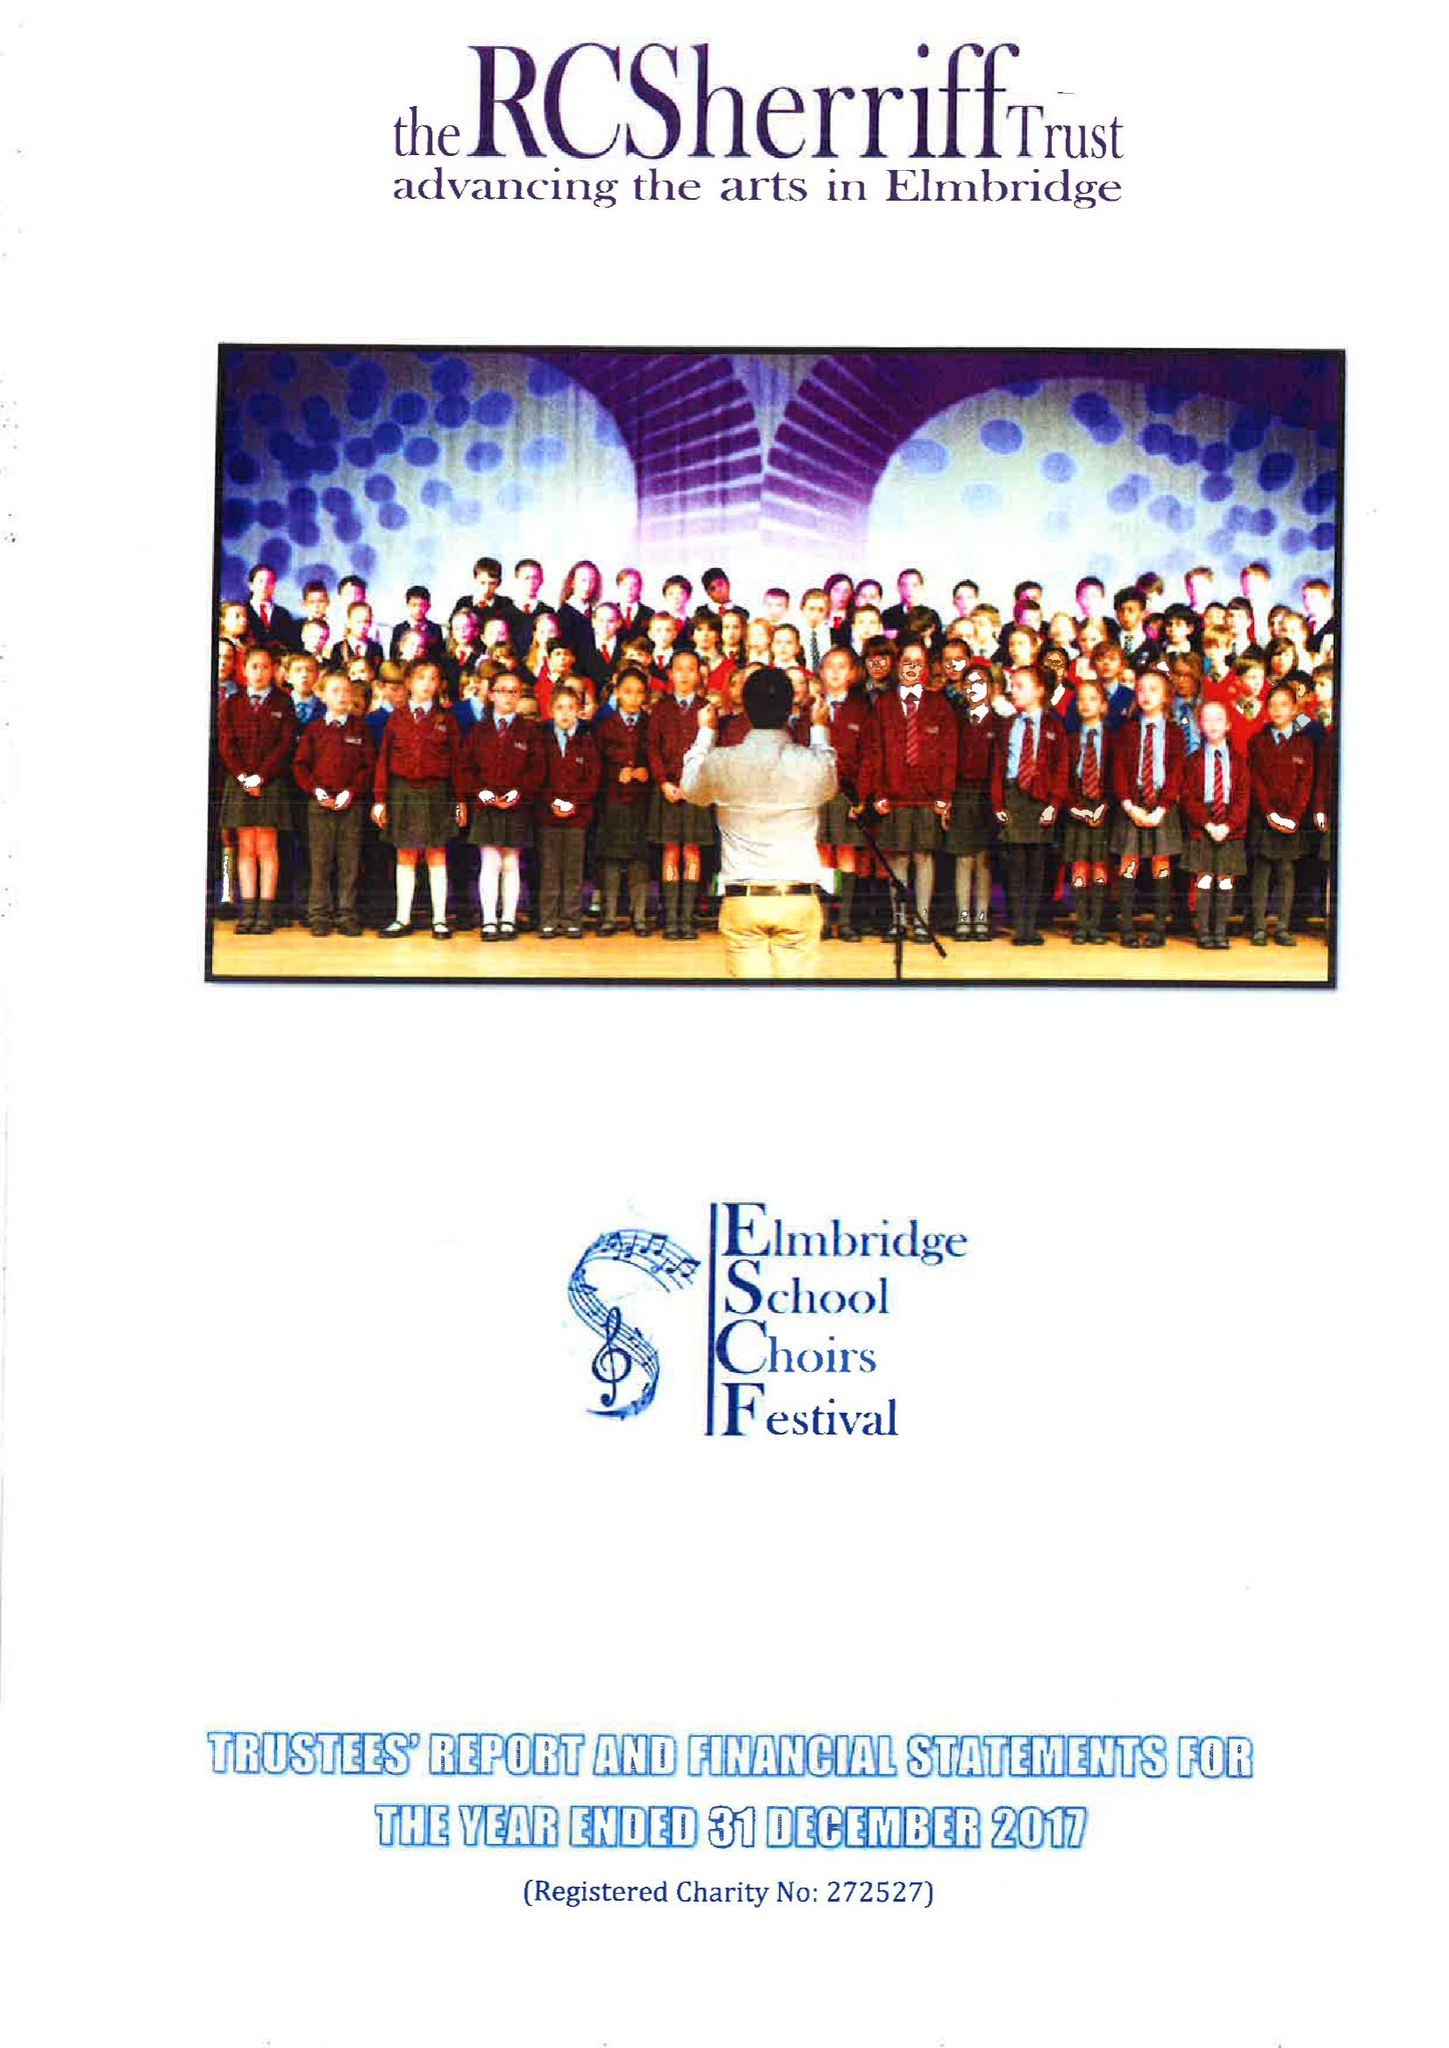What is the value for the charity_name?
Answer the question using a single word or phrase. The Rc Sherriff Rosebriars Trust 